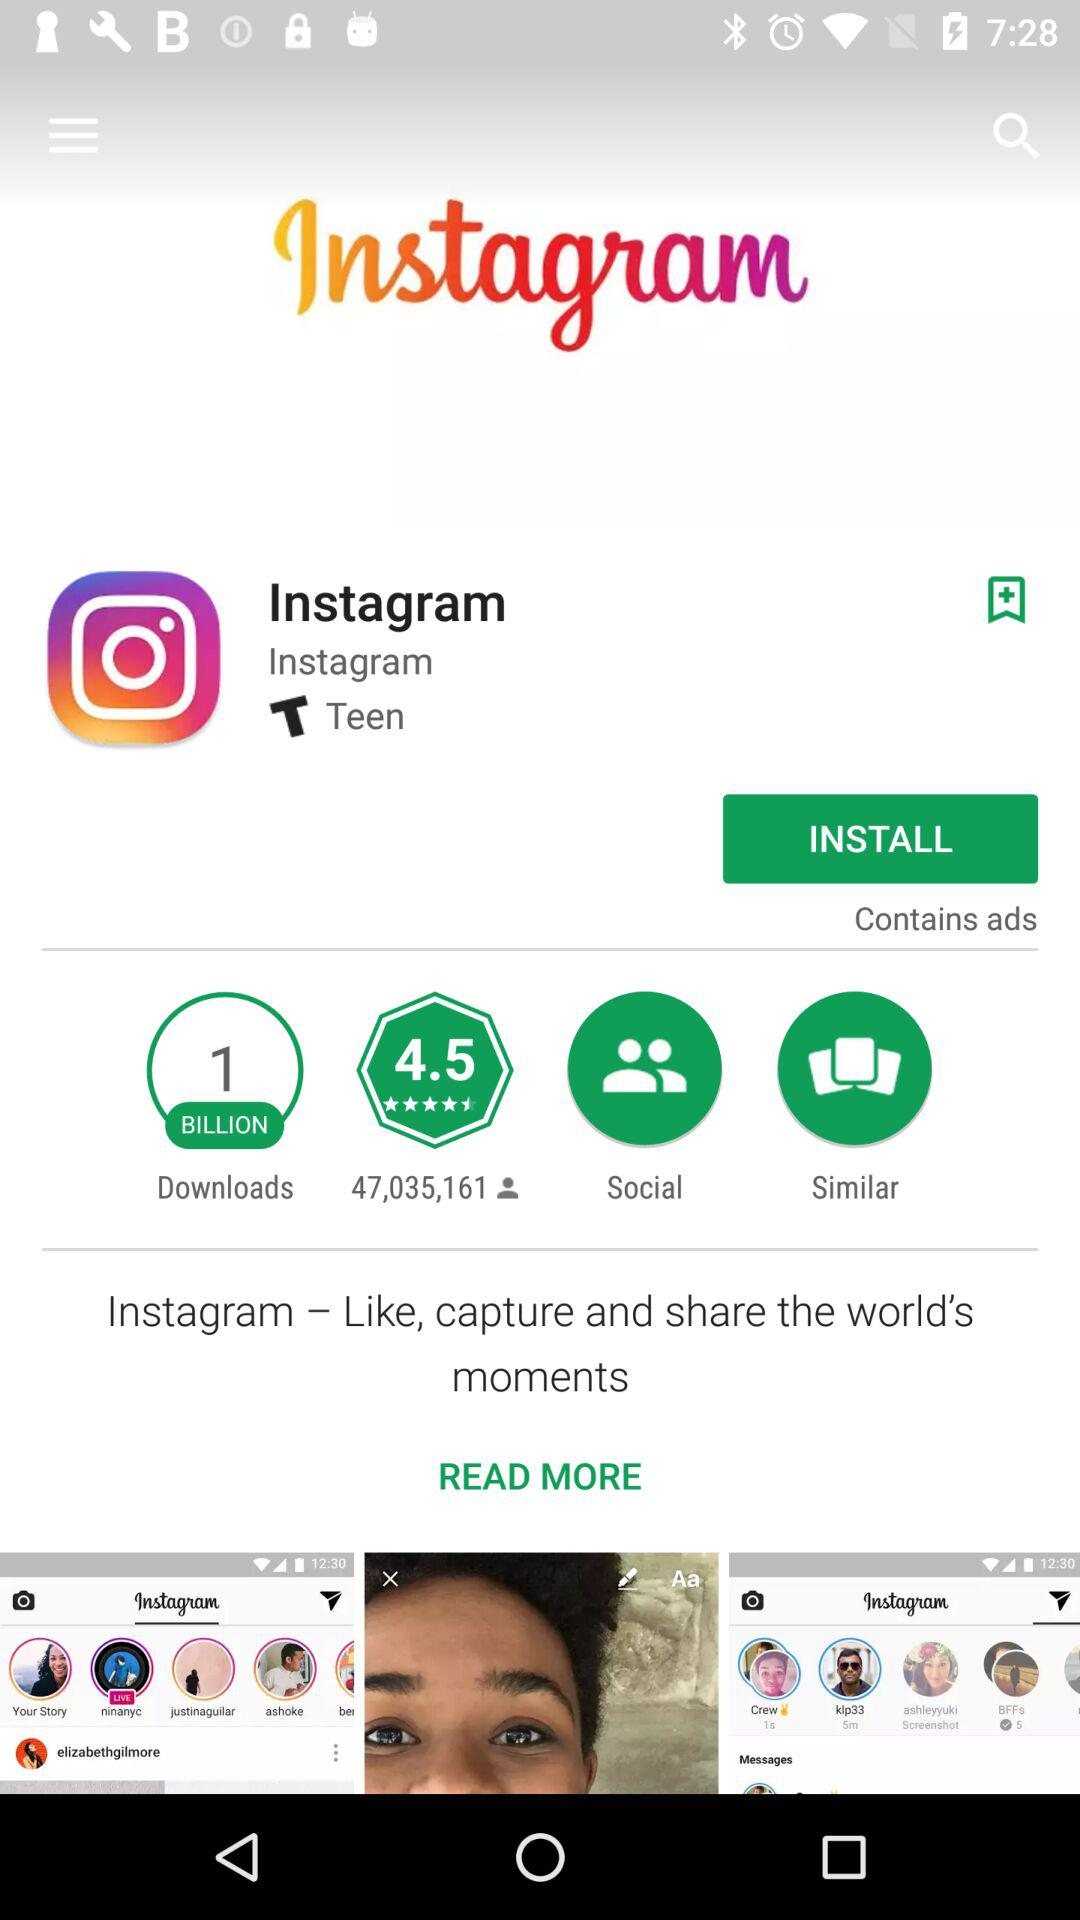How many users have rated "Instagram"? The number of users who have rated "Instagram" are 47,035,161. 